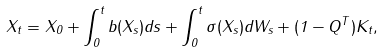<formula> <loc_0><loc_0><loc_500><loc_500>X _ { t } = X _ { 0 } + \int _ { 0 } ^ { t } b ( X _ { s } ) d s + \int _ { 0 } ^ { t } \sigma ( X _ { s } ) d W _ { s } + ( 1 - Q ^ { T } ) K _ { t } ,</formula> 